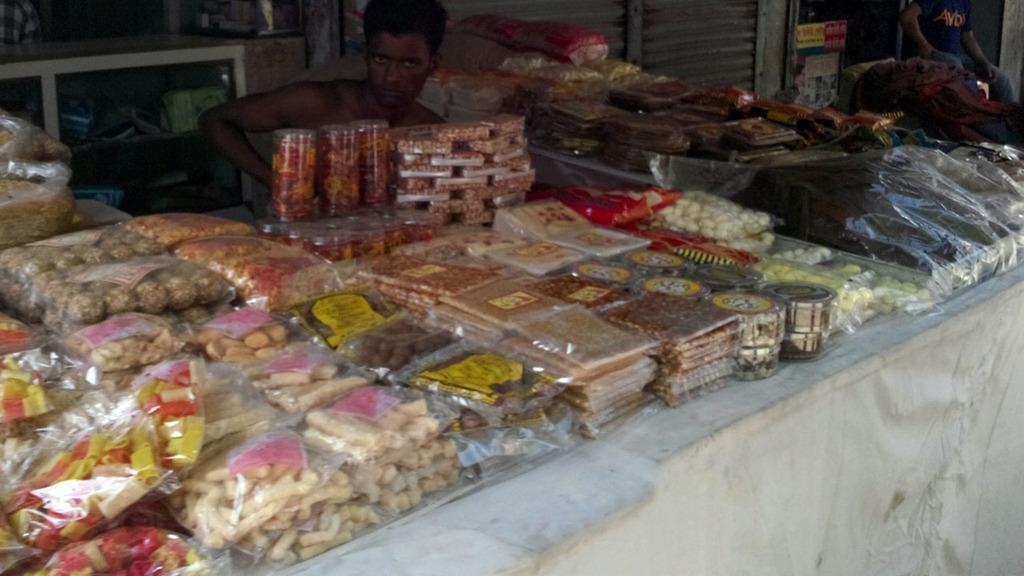What can be seen in the image in terms of food items? There are many food item packs in the image. Can you describe the people present in the image? There is a person sitting at the back of the image, and another person is present at the right back of the image. What else is visible in the image? There is a shutter in the image. Is there a volcano erupting in the image? No, there is no volcano or any indication of an eruption in the image. Can you tell me how many carts are present in the image? There is no mention of a cart or any similar object in the image. 